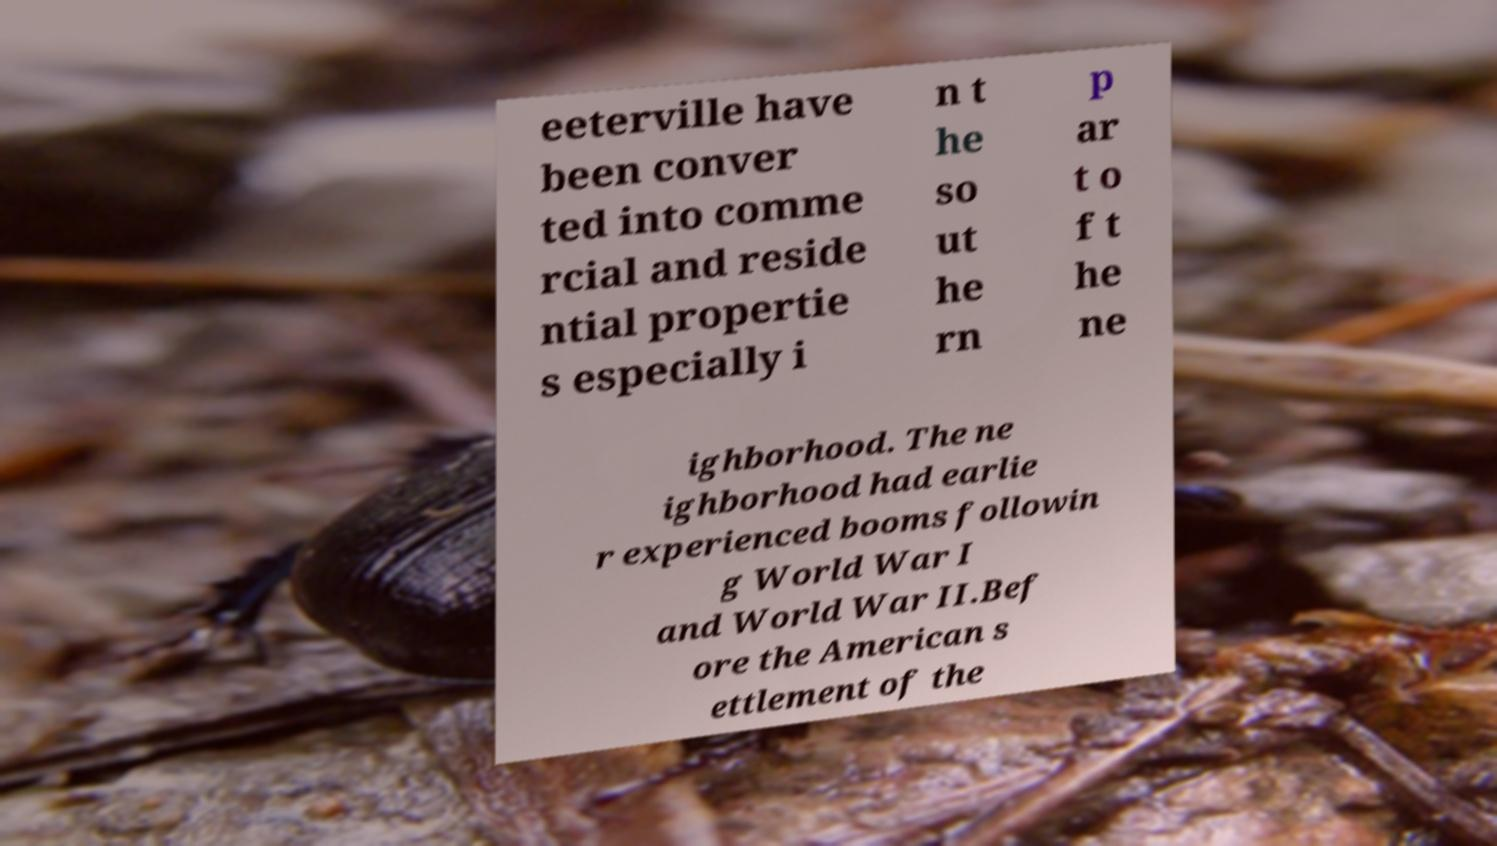There's text embedded in this image that I need extracted. Can you transcribe it verbatim? eeterville have been conver ted into comme rcial and reside ntial propertie s especially i n t he so ut he rn p ar t o f t he ne ighborhood. The ne ighborhood had earlie r experienced booms followin g World War I and World War II.Bef ore the American s ettlement of the 